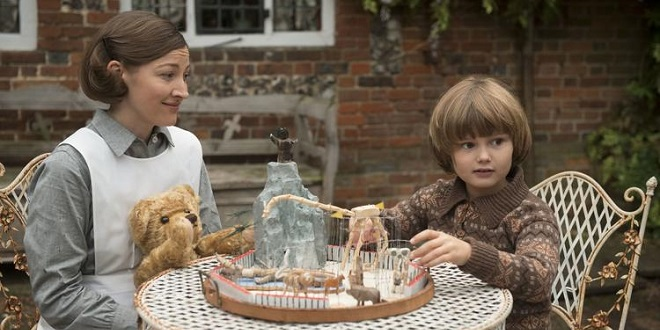If this scene were part of a nostalgic movie, what might be the storyline? In the nostalgic movie, this scene is part of a heartwarming tale about a young boy named Timothy, growing up in a small village. During the summer, Timothy spends his afternoons at his grandmother's house, who happens to be Kelly, a retired school teacher. She loves sharing stories and engaging in imaginative play with Timothy. The white table is their special sanctuary where Timothy escapes his reality and dives into tales of adventure and wonder. The movie follows Timothy's journey as he navigates childhood, learning important life lessons, and building cherished memories with his grandmother. Their bond deepens with each passing adventure spun from their imaginations, captured in moments like the one at the toy carousel. The backdrop of the rustic brick wall and their cozy corner becomes symbolic of Timothy's safe haven, a place where love and imagination know no bounds. 